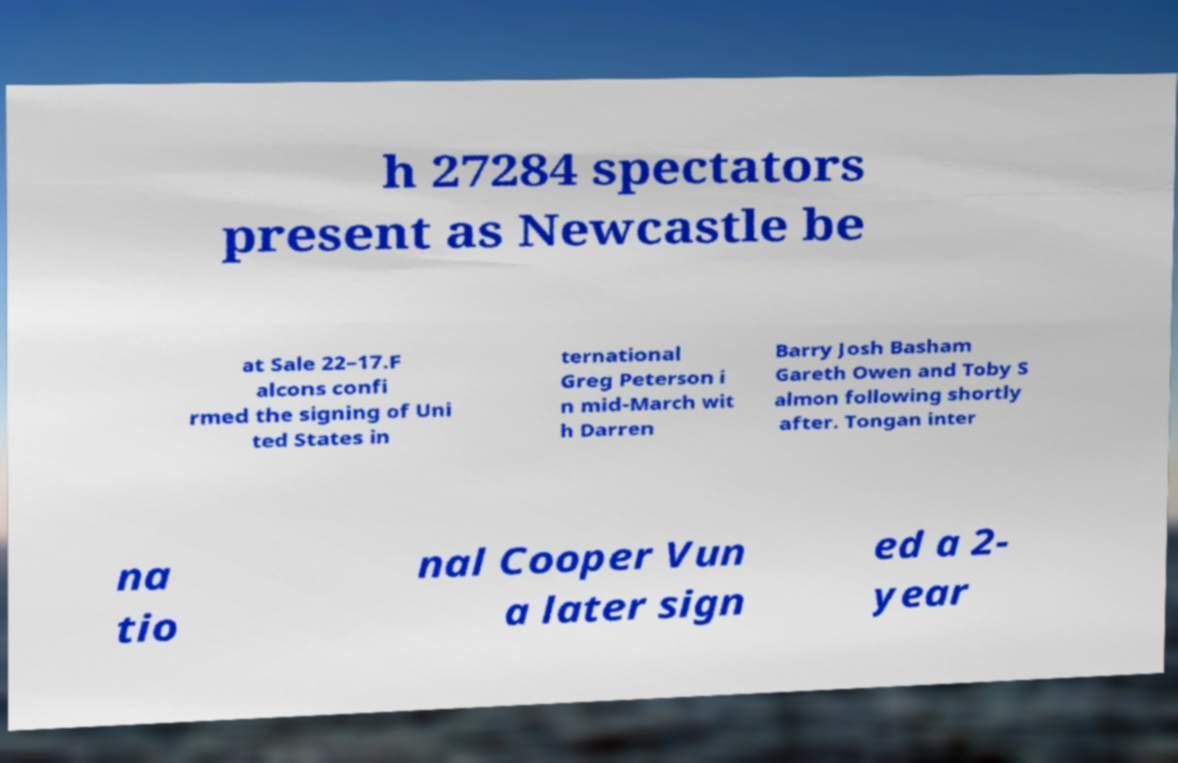Could you assist in decoding the text presented in this image and type it out clearly? h 27284 spectators present as Newcastle be at Sale 22–17.F alcons confi rmed the signing of Uni ted States in ternational Greg Peterson i n mid-March wit h Darren Barry Josh Basham Gareth Owen and Toby S almon following shortly after. Tongan inter na tio nal Cooper Vun a later sign ed a 2- year 